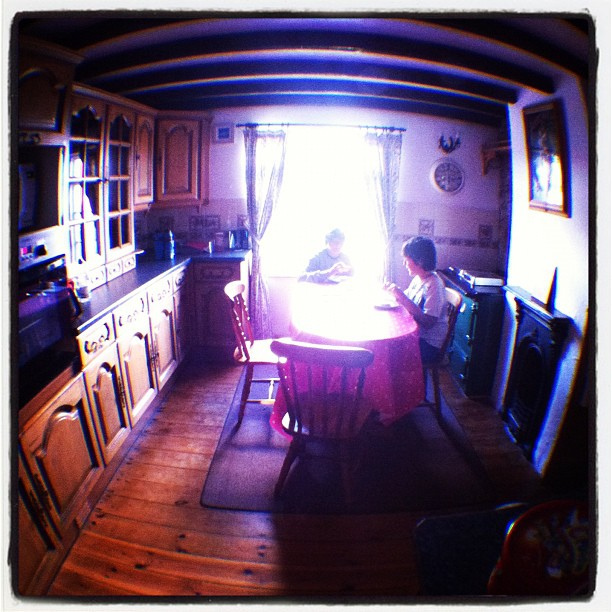What details can you tell me about the window treatment? The window is adorned with a sheer curtain that diffuses the incoming light, generating a soft glow which enhances the mood of the setting. It is accompanied by a heavier curtain on one side, suggesting that there might be a matching curtain that could be drawn for privacy or to block out light when desired. 